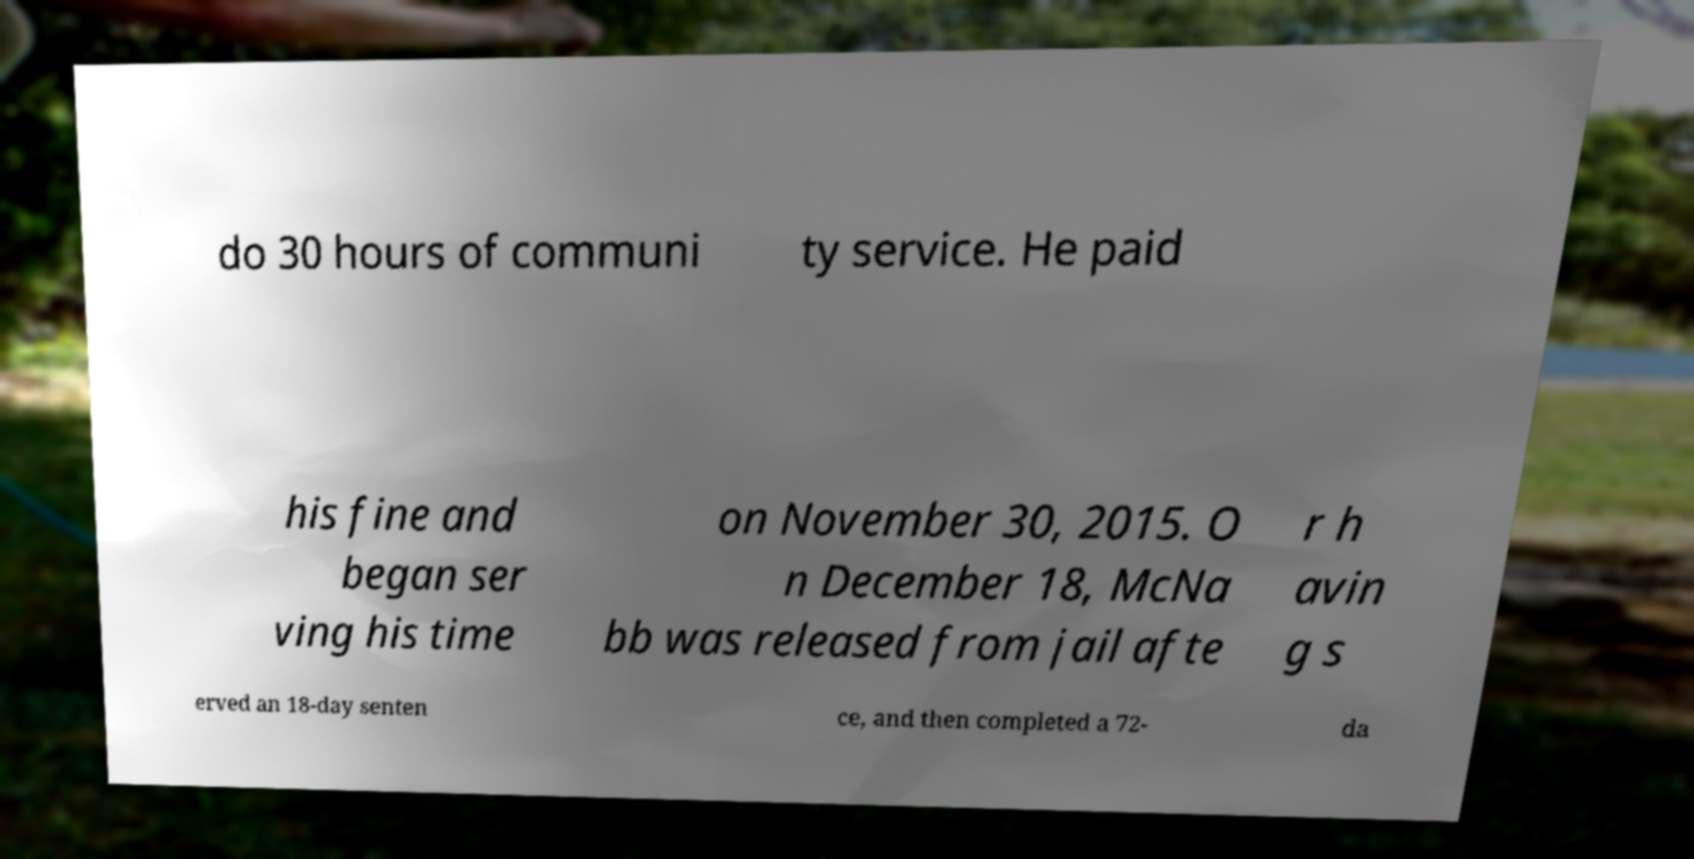Can you accurately transcribe the text from the provided image for me? do 30 hours of communi ty service. He paid his fine and began ser ving his time on November 30, 2015. O n December 18, McNa bb was released from jail afte r h avin g s erved an 18-day senten ce, and then completed a 72- da 